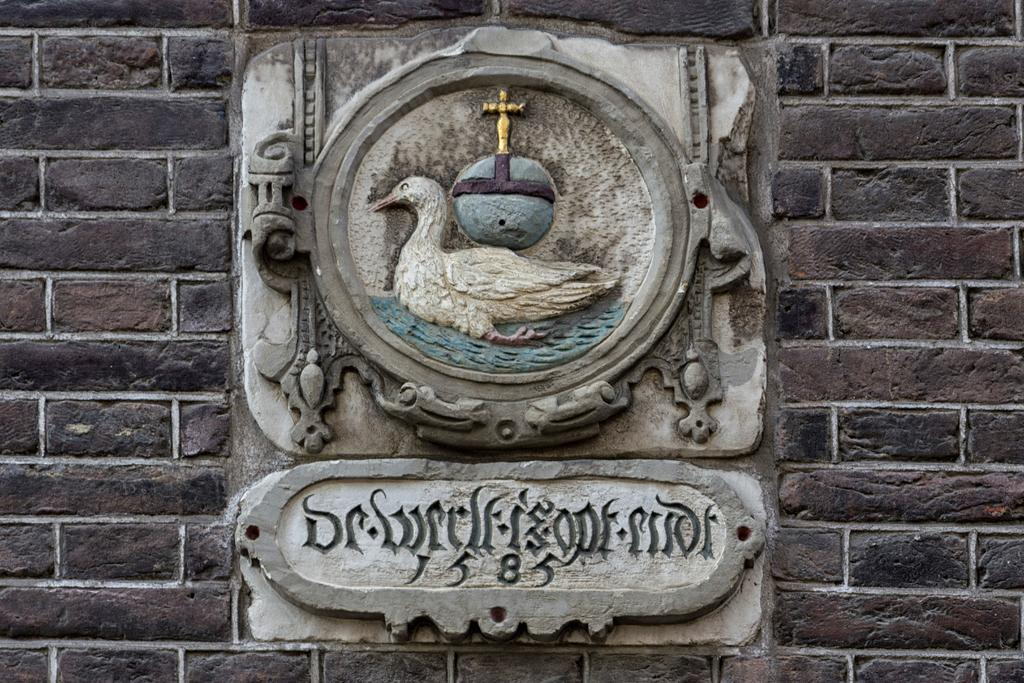What is on the wall in the image? There is a sculpture on the wall in the image. What is located below the sculpture? There is some text below the sculpture in the image. What type of flesh can be seen in the image? There is no flesh present in the image; it features a sculpture on the wall and text below it. What kind of record is being played in the image? There is no record or music player present in the image. 